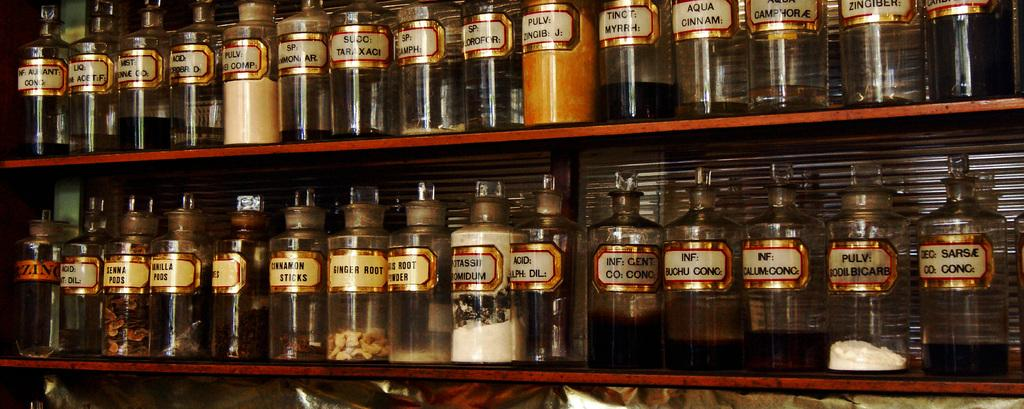What type of containers are visible in the image? There are glass jars in the image. How are the glass jars arranged in the image? The glass jars are arranged on two shelves. What can be found inside the glass jars? There are food items in the glass jars. Can you see any trees or volcanoes in the image? No, there are no trees or volcanoes present in the image. 